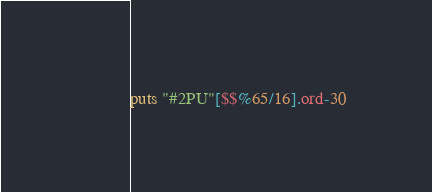Convert code to text. <code><loc_0><loc_0><loc_500><loc_500><_Ruby_>puts "#2PU"[$$%65/16].ord-30</code> 